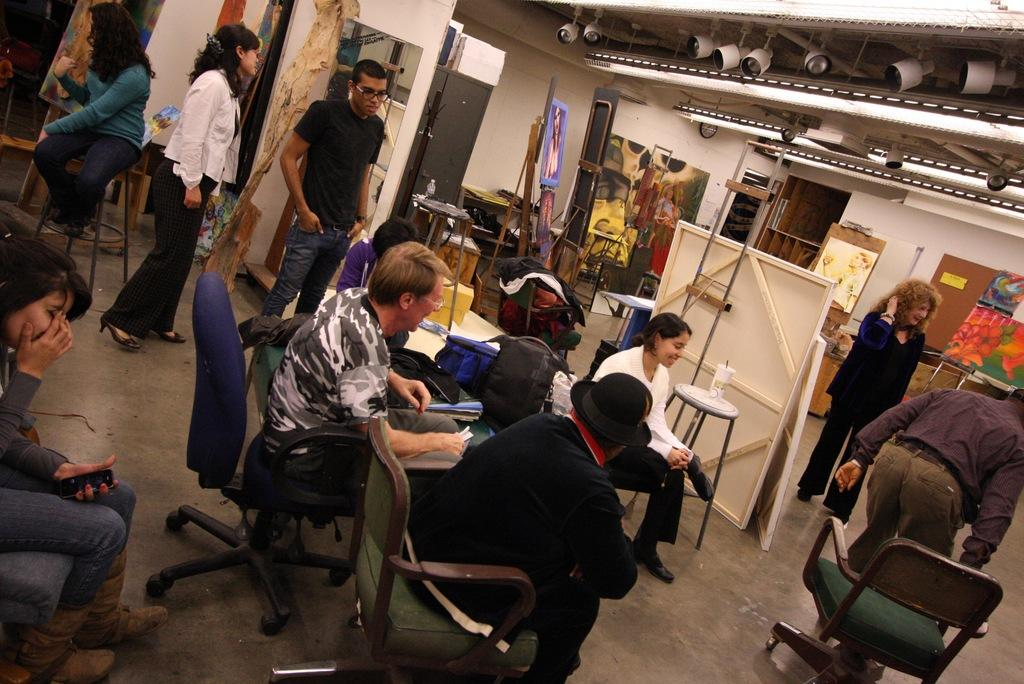How many people are in the image? There is a group of people in the image, but the exact number cannot be determined from the provided facts. What are some of the people in the image doing? Some people are sitting on chairs, while others are standing. What can be seen on the boards in the image? The provided facts do not specify what is on the boards. What is the background of the image? There is a wall in the image, which suggests that the background is likely indoors. Can you describe any other objects present in the image? The provided facts mention that there are other objects present in the image, but their specific nature cannot be determined. What letter is being written on the nose of the person in the image? There is no mention of a letter or a person writing on someone's nose in the provided facts, so this question cannot be answered definitively. 